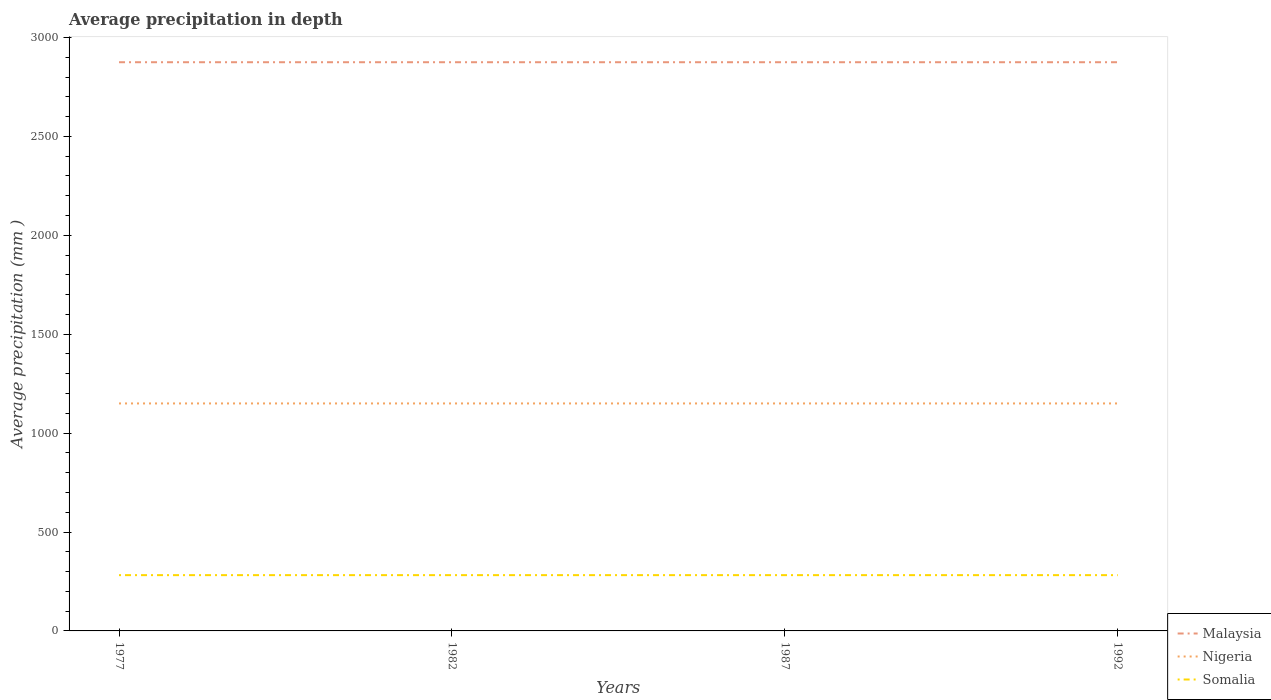How many different coloured lines are there?
Your answer should be compact. 3. Does the line corresponding to Nigeria intersect with the line corresponding to Malaysia?
Provide a short and direct response. No. Across all years, what is the maximum average precipitation in Somalia?
Give a very brief answer. 282. In which year was the average precipitation in Nigeria maximum?
Keep it short and to the point. 1977. What is the total average precipitation in Nigeria in the graph?
Keep it short and to the point. 0. What is the difference between the highest and the lowest average precipitation in Malaysia?
Offer a very short reply. 0. Is the average precipitation in Malaysia strictly greater than the average precipitation in Somalia over the years?
Your response must be concise. No. Are the values on the major ticks of Y-axis written in scientific E-notation?
Offer a terse response. No. Does the graph contain any zero values?
Provide a short and direct response. No. How many legend labels are there?
Your answer should be very brief. 3. What is the title of the graph?
Your answer should be compact. Average precipitation in depth. What is the label or title of the Y-axis?
Make the answer very short. Average precipitation (mm ). What is the Average precipitation (mm ) of Malaysia in 1977?
Ensure brevity in your answer.  2875. What is the Average precipitation (mm ) of Nigeria in 1977?
Your response must be concise. 1150. What is the Average precipitation (mm ) of Somalia in 1977?
Provide a succinct answer. 282. What is the Average precipitation (mm ) of Malaysia in 1982?
Provide a succinct answer. 2875. What is the Average precipitation (mm ) in Nigeria in 1982?
Provide a short and direct response. 1150. What is the Average precipitation (mm ) in Somalia in 1982?
Provide a succinct answer. 282. What is the Average precipitation (mm ) in Malaysia in 1987?
Provide a short and direct response. 2875. What is the Average precipitation (mm ) of Nigeria in 1987?
Give a very brief answer. 1150. What is the Average precipitation (mm ) of Somalia in 1987?
Provide a succinct answer. 282. What is the Average precipitation (mm ) of Malaysia in 1992?
Offer a very short reply. 2875. What is the Average precipitation (mm ) of Nigeria in 1992?
Make the answer very short. 1150. What is the Average precipitation (mm ) of Somalia in 1992?
Keep it short and to the point. 282. Across all years, what is the maximum Average precipitation (mm ) of Malaysia?
Offer a terse response. 2875. Across all years, what is the maximum Average precipitation (mm ) in Nigeria?
Your response must be concise. 1150. Across all years, what is the maximum Average precipitation (mm ) in Somalia?
Give a very brief answer. 282. Across all years, what is the minimum Average precipitation (mm ) of Malaysia?
Give a very brief answer. 2875. Across all years, what is the minimum Average precipitation (mm ) in Nigeria?
Your answer should be compact. 1150. Across all years, what is the minimum Average precipitation (mm ) in Somalia?
Your answer should be very brief. 282. What is the total Average precipitation (mm ) in Malaysia in the graph?
Your response must be concise. 1.15e+04. What is the total Average precipitation (mm ) in Nigeria in the graph?
Ensure brevity in your answer.  4600. What is the total Average precipitation (mm ) of Somalia in the graph?
Offer a very short reply. 1128. What is the difference between the Average precipitation (mm ) in Malaysia in 1977 and that in 1982?
Provide a short and direct response. 0. What is the difference between the Average precipitation (mm ) of Nigeria in 1977 and that in 1982?
Ensure brevity in your answer.  0. What is the difference between the Average precipitation (mm ) in Somalia in 1977 and that in 1982?
Provide a succinct answer. 0. What is the difference between the Average precipitation (mm ) of Malaysia in 1977 and that in 1987?
Offer a very short reply. 0. What is the difference between the Average precipitation (mm ) of Nigeria in 1977 and that in 1987?
Keep it short and to the point. 0. What is the difference between the Average precipitation (mm ) of Somalia in 1977 and that in 1987?
Provide a short and direct response. 0. What is the difference between the Average precipitation (mm ) in Malaysia in 1977 and that in 1992?
Make the answer very short. 0. What is the difference between the Average precipitation (mm ) in Malaysia in 1982 and that in 1987?
Offer a very short reply. 0. What is the difference between the Average precipitation (mm ) in Malaysia in 1982 and that in 1992?
Offer a terse response. 0. What is the difference between the Average precipitation (mm ) of Nigeria in 1982 and that in 1992?
Your response must be concise. 0. What is the difference between the Average precipitation (mm ) in Malaysia in 1977 and the Average precipitation (mm ) in Nigeria in 1982?
Provide a succinct answer. 1725. What is the difference between the Average precipitation (mm ) of Malaysia in 1977 and the Average precipitation (mm ) of Somalia in 1982?
Your response must be concise. 2593. What is the difference between the Average precipitation (mm ) of Nigeria in 1977 and the Average precipitation (mm ) of Somalia in 1982?
Keep it short and to the point. 868. What is the difference between the Average precipitation (mm ) of Malaysia in 1977 and the Average precipitation (mm ) of Nigeria in 1987?
Provide a short and direct response. 1725. What is the difference between the Average precipitation (mm ) in Malaysia in 1977 and the Average precipitation (mm ) in Somalia in 1987?
Give a very brief answer. 2593. What is the difference between the Average precipitation (mm ) of Nigeria in 1977 and the Average precipitation (mm ) of Somalia in 1987?
Your answer should be very brief. 868. What is the difference between the Average precipitation (mm ) of Malaysia in 1977 and the Average precipitation (mm ) of Nigeria in 1992?
Offer a terse response. 1725. What is the difference between the Average precipitation (mm ) of Malaysia in 1977 and the Average precipitation (mm ) of Somalia in 1992?
Offer a very short reply. 2593. What is the difference between the Average precipitation (mm ) in Nigeria in 1977 and the Average precipitation (mm ) in Somalia in 1992?
Offer a very short reply. 868. What is the difference between the Average precipitation (mm ) in Malaysia in 1982 and the Average precipitation (mm ) in Nigeria in 1987?
Make the answer very short. 1725. What is the difference between the Average precipitation (mm ) in Malaysia in 1982 and the Average precipitation (mm ) in Somalia in 1987?
Your answer should be compact. 2593. What is the difference between the Average precipitation (mm ) in Nigeria in 1982 and the Average precipitation (mm ) in Somalia in 1987?
Keep it short and to the point. 868. What is the difference between the Average precipitation (mm ) of Malaysia in 1982 and the Average precipitation (mm ) of Nigeria in 1992?
Your answer should be compact. 1725. What is the difference between the Average precipitation (mm ) in Malaysia in 1982 and the Average precipitation (mm ) in Somalia in 1992?
Provide a succinct answer. 2593. What is the difference between the Average precipitation (mm ) of Nigeria in 1982 and the Average precipitation (mm ) of Somalia in 1992?
Offer a very short reply. 868. What is the difference between the Average precipitation (mm ) in Malaysia in 1987 and the Average precipitation (mm ) in Nigeria in 1992?
Your answer should be very brief. 1725. What is the difference between the Average precipitation (mm ) in Malaysia in 1987 and the Average precipitation (mm ) in Somalia in 1992?
Offer a very short reply. 2593. What is the difference between the Average precipitation (mm ) in Nigeria in 1987 and the Average precipitation (mm ) in Somalia in 1992?
Provide a short and direct response. 868. What is the average Average precipitation (mm ) in Malaysia per year?
Ensure brevity in your answer.  2875. What is the average Average precipitation (mm ) in Nigeria per year?
Provide a short and direct response. 1150. What is the average Average precipitation (mm ) of Somalia per year?
Keep it short and to the point. 282. In the year 1977, what is the difference between the Average precipitation (mm ) in Malaysia and Average precipitation (mm ) in Nigeria?
Keep it short and to the point. 1725. In the year 1977, what is the difference between the Average precipitation (mm ) of Malaysia and Average precipitation (mm ) of Somalia?
Your answer should be very brief. 2593. In the year 1977, what is the difference between the Average precipitation (mm ) in Nigeria and Average precipitation (mm ) in Somalia?
Your answer should be compact. 868. In the year 1982, what is the difference between the Average precipitation (mm ) of Malaysia and Average precipitation (mm ) of Nigeria?
Offer a terse response. 1725. In the year 1982, what is the difference between the Average precipitation (mm ) in Malaysia and Average precipitation (mm ) in Somalia?
Make the answer very short. 2593. In the year 1982, what is the difference between the Average precipitation (mm ) in Nigeria and Average precipitation (mm ) in Somalia?
Your answer should be compact. 868. In the year 1987, what is the difference between the Average precipitation (mm ) of Malaysia and Average precipitation (mm ) of Nigeria?
Provide a succinct answer. 1725. In the year 1987, what is the difference between the Average precipitation (mm ) of Malaysia and Average precipitation (mm ) of Somalia?
Ensure brevity in your answer.  2593. In the year 1987, what is the difference between the Average precipitation (mm ) in Nigeria and Average precipitation (mm ) in Somalia?
Keep it short and to the point. 868. In the year 1992, what is the difference between the Average precipitation (mm ) of Malaysia and Average precipitation (mm ) of Nigeria?
Provide a short and direct response. 1725. In the year 1992, what is the difference between the Average precipitation (mm ) in Malaysia and Average precipitation (mm ) in Somalia?
Offer a very short reply. 2593. In the year 1992, what is the difference between the Average precipitation (mm ) of Nigeria and Average precipitation (mm ) of Somalia?
Offer a very short reply. 868. What is the ratio of the Average precipitation (mm ) in Somalia in 1977 to that in 1982?
Keep it short and to the point. 1. What is the ratio of the Average precipitation (mm ) of Somalia in 1977 to that in 1992?
Your answer should be compact. 1. What is the ratio of the Average precipitation (mm ) in Somalia in 1982 to that in 1992?
Your response must be concise. 1. What is the ratio of the Average precipitation (mm ) in Nigeria in 1987 to that in 1992?
Your answer should be compact. 1. What is the ratio of the Average precipitation (mm ) of Somalia in 1987 to that in 1992?
Your response must be concise. 1. What is the difference between the highest and the second highest Average precipitation (mm ) of Nigeria?
Your answer should be compact. 0. What is the difference between the highest and the second highest Average precipitation (mm ) in Somalia?
Your answer should be very brief. 0. What is the difference between the highest and the lowest Average precipitation (mm ) of Malaysia?
Your response must be concise. 0. What is the difference between the highest and the lowest Average precipitation (mm ) in Somalia?
Keep it short and to the point. 0. 